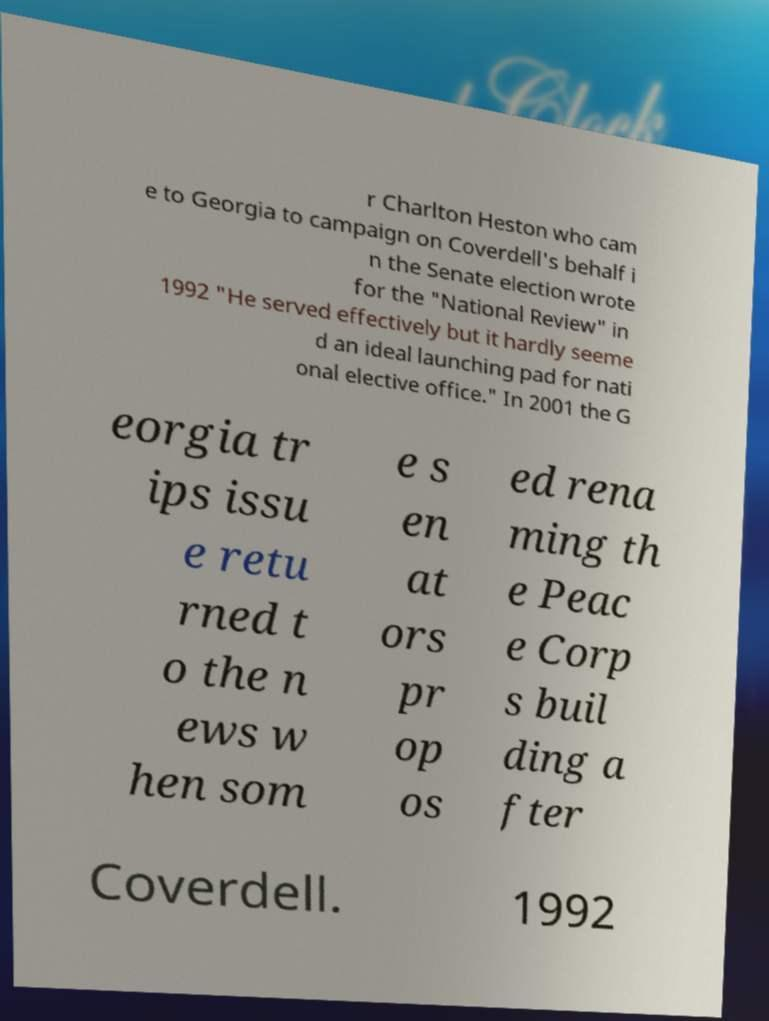There's text embedded in this image that I need extracted. Can you transcribe it verbatim? r Charlton Heston who cam e to Georgia to campaign on Coverdell's behalf i n the Senate election wrote for the "National Review" in 1992 "He served effectively but it hardly seeme d an ideal launching pad for nati onal elective office." In 2001 the G eorgia tr ips issu e retu rned t o the n ews w hen som e s en at ors pr op os ed rena ming th e Peac e Corp s buil ding a fter Coverdell. 1992 